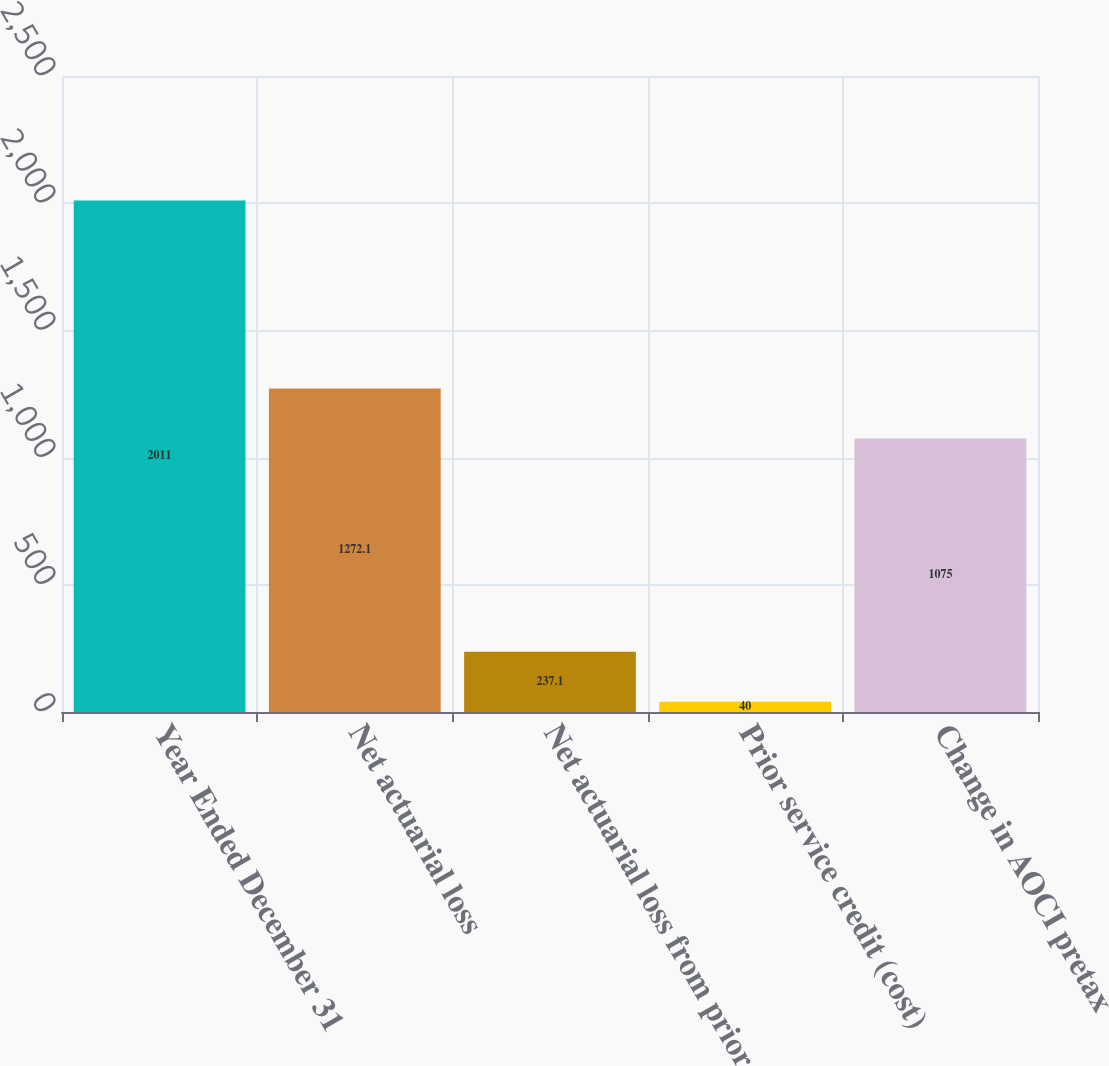Convert chart to OTSL. <chart><loc_0><loc_0><loc_500><loc_500><bar_chart><fcel>Year Ended December 31<fcel>Net actuarial loss<fcel>Net actuarial loss from prior<fcel>Prior service credit (cost)<fcel>Change in AOCI pretax<nl><fcel>2011<fcel>1272.1<fcel>237.1<fcel>40<fcel>1075<nl></chart> 